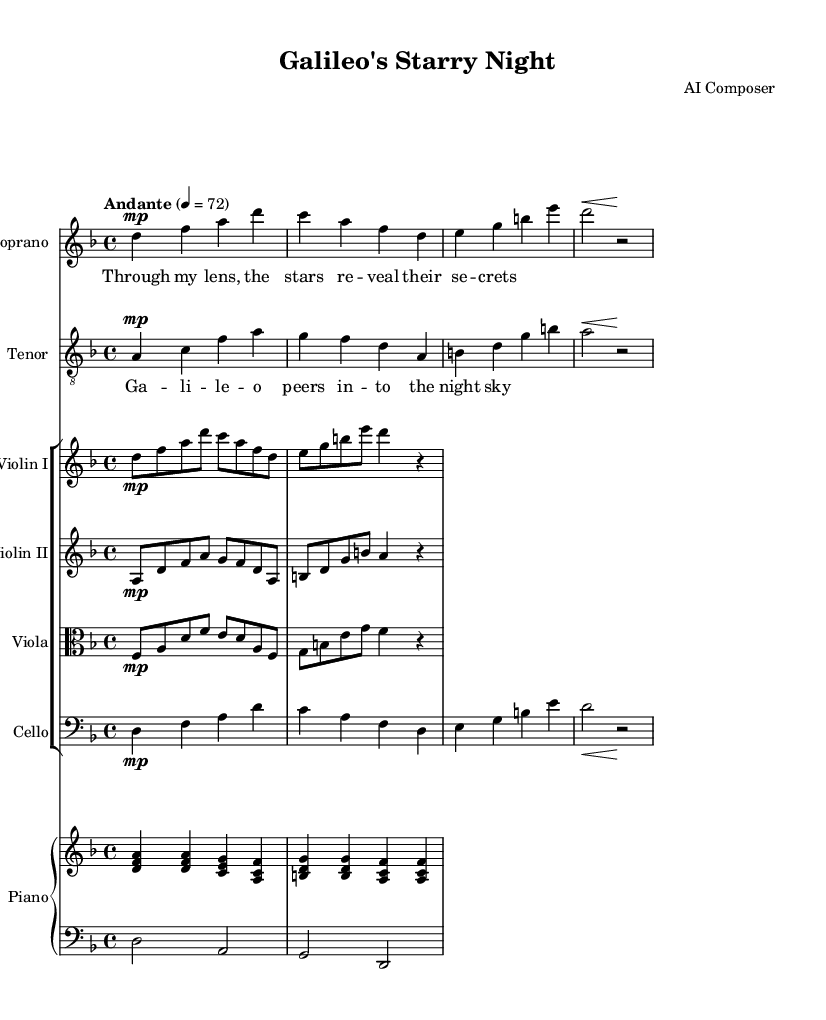What is the key signature of this music? The key signature is indicated in the global settings as "d minor", which has one flat (B flat).
Answer: d minor What is the time signature of this piece? The time signature is indicated in the global settings as "4/4", meaning there are four beats in each measure.
Answer: 4/4 What is the tempo marking of the piece? The tempo marking is noted in the global settings as "Andante", which indicates a moderate walking pace, and the metronome marking is 72 beats per minute.
Answer: Andante What instruments are included in the orchestration? The orchestration includes Soprano, Tenor, Violin I, Violin II, Viola, Cello, and Piano.
Answer: Soprano, Tenor, Violin I, Violin II, Viola, Cello, Piano How many voices are in this opera score? There are two distinct vocal parts: Soprano and Tenor. This is indicated by separate staff sections for each vocal line.
Answer: Two What is the dynamic marking for the cello part? The cello part has a dynamic marking of "mp" which stands for mezzo-piano, indicating a moderately soft dynamic level.
Answer: mp What theme is explored in the opera as indicated by the lyrics? The lyrics provided for the Soprano and Tenor sections suggest themes of stargazing and discovery, specifically referencing Galileo and the insights gained from observing the night sky.
Answer: Stargazing and discovery 